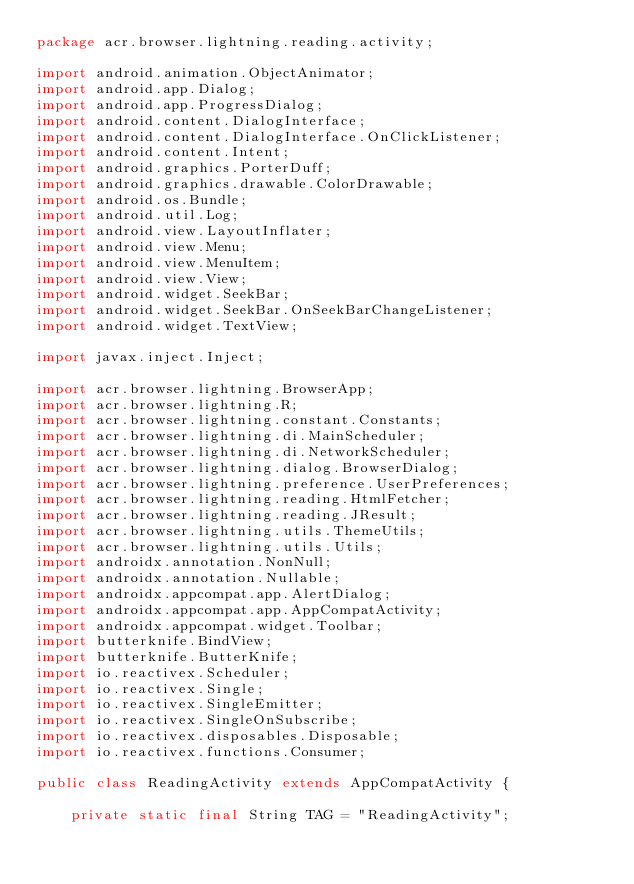Convert code to text. <code><loc_0><loc_0><loc_500><loc_500><_Java_>package acr.browser.lightning.reading.activity;

import android.animation.ObjectAnimator;
import android.app.Dialog;
import android.app.ProgressDialog;
import android.content.DialogInterface;
import android.content.DialogInterface.OnClickListener;
import android.content.Intent;
import android.graphics.PorterDuff;
import android.graphics.drawable.ColorDrawable;
import android.os.Bundle;
import android.util.Log;
import android.view.LayoutInflater;
import android.view.Menu;
import android.view.MenuItem;
import android.view.View;
import android.widget.SeekBar;
import android.widget.SeekBar.OnSeekBarChangeListener;
import android.widget.TextView;

import javax.inject.Inject;

import acr.browser.lightning.BrowserApp;
import acr.browser.lightning.R;
import acr.browser.lightning.constant.Constants;
import acr.browser.lightning.di.MainScheduler;
import acr.browser.lightning.di.NetworkScheduler;
import acr.browser.lightning.dialog.BrowserDialog;
import acr.browser.lightning.preference.UserPreferences;
import acr.browser.lightning.reading.HtmlFetcher;
import acr.browser.lightning.reading.JResult;
import acr.browser.lightning.utils.ThemeUtils;
import acr.browser.lightning.utils.Utils;
import androidx.annotation.NonNull;
import androidx.annotation.Nullable;
import androidx.appcompat.app.AlertDialog;
import androidx.appcompat.app.AppCompatActivity;
import androidx.appcompat.widget.Toolbar;
import butterknife.BindView;
import butterknife.ButterKnife;
import io.reactivex.Scheduler;
import io.reactivex.Single;
import io.reactivex.SingleEmitter;
import io.reactivex.SingleOnSubscribe;
import io.reactivex.disposables.Disposable;
import io.reactivex.functions.Consumer;

public class ReadingActivity extends AppCompatActivity {

    private static final String TAG = "ReadingActivity";
</code> 